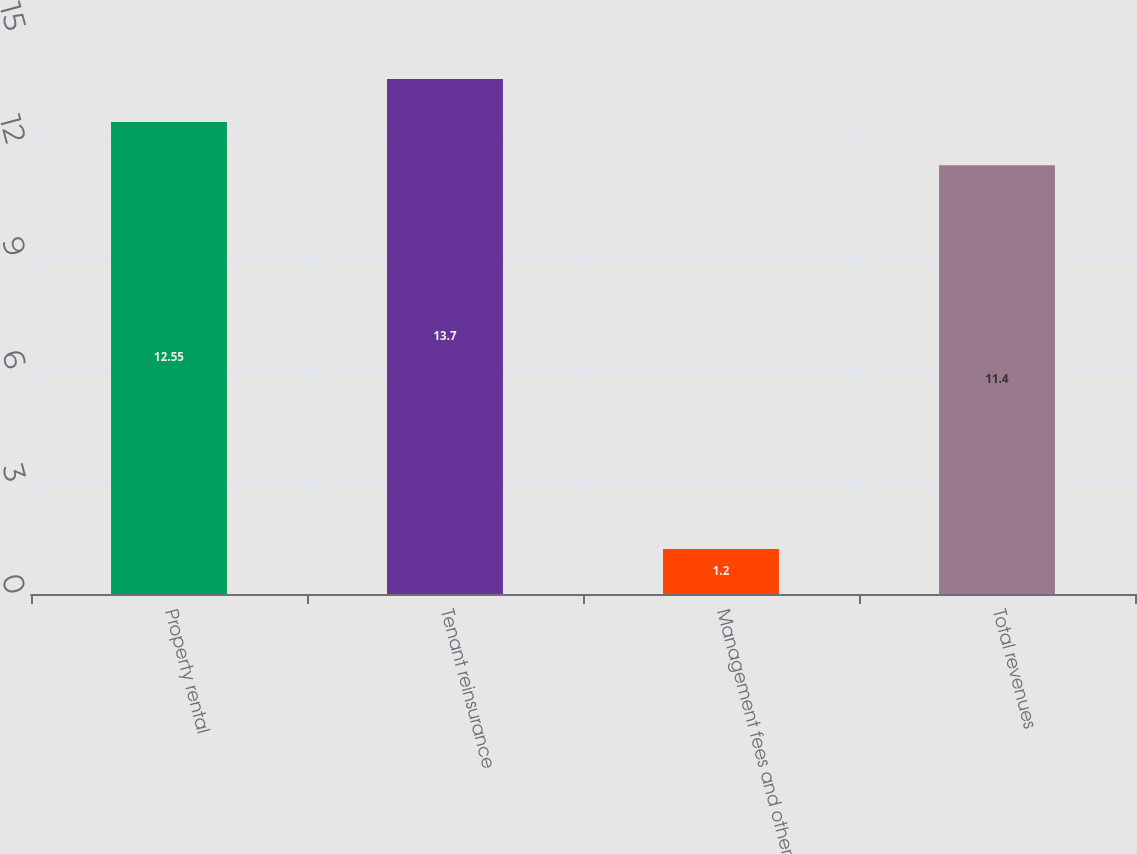Convert chart. <chart><loc_0><loc_0><loc_500><loc_500><bar_chart><fcel>Property rental<fcel>Tenant reinsurance<fcel>Management fees and other<fcel>Total revenues<nl><fcel>12.55<fcel>13.7<fcel>1.2<fcel>11.4<nl></chart> 